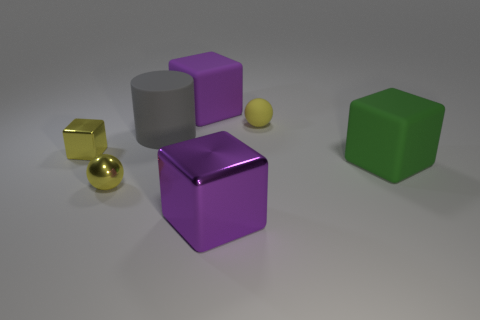There is a cylinder; are there any large objects behind it?
Offer a terse response. Yes. How many purple metal objects are the same shape as the big green object?
Provide a succinct answer. 1. Do the gray thing and the yellow ball in front of the rubber ball have the same material?
Your answer should be very brief. No. What number of small matte objects are there?
Provide a short and direct response. 1. There is a yellow ball that is on the right side of the purple matte cube; what size is it?
Your answer should be compact. Small. How many metal spheres are the same size as the yellow rubber thing?
Make the answer very short. 1. What is the large cube that is left of the rubber sphere and in front of the gray cylinder made of?
Give a very brief answer. Metal. What material is the purple cube that is the same size as the purple matte object?
Your answer should be compact. Metal. There is a matte cube to the right of the purple block behind the shiny thing that is in front of the tiny metal sphere; what size is it?
Your answer should be very brief. Large. There is a green thing that is the same material as the big cylinder; what size is it?
Keep it short and to the point. Large. 